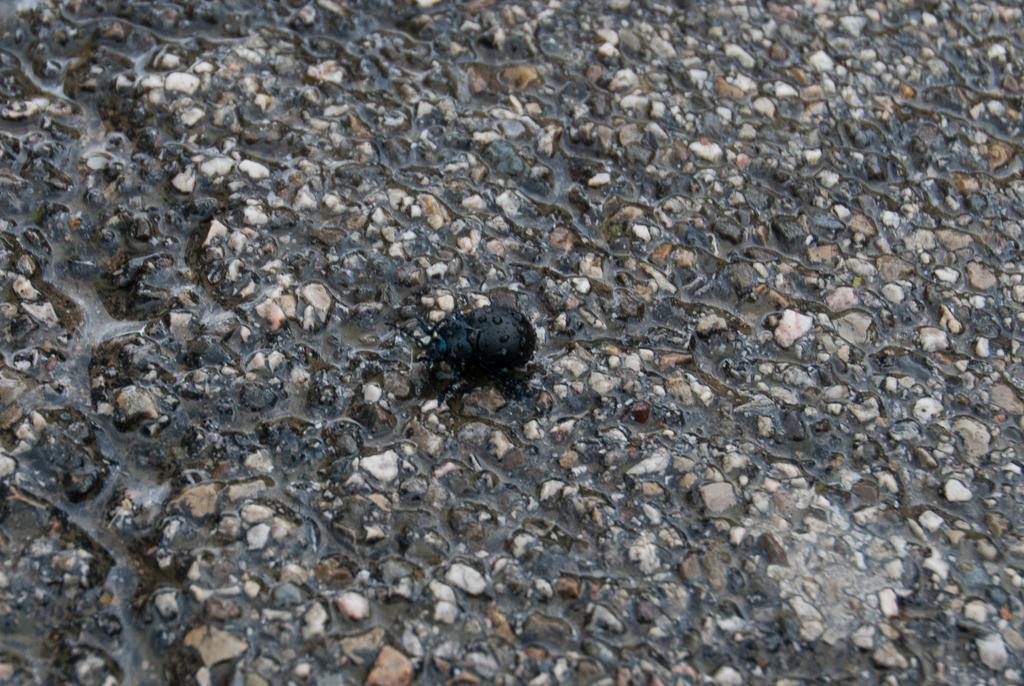What type of insect is in the image? There is a beetle in the image. What color is the beetle? The beetle is black in color. Where is the beetle located in the image? The beetle is on a path. Is there a heart-shaped lake visible in the image? There is no lake, heart-shaped or otherwise, present in the image. 